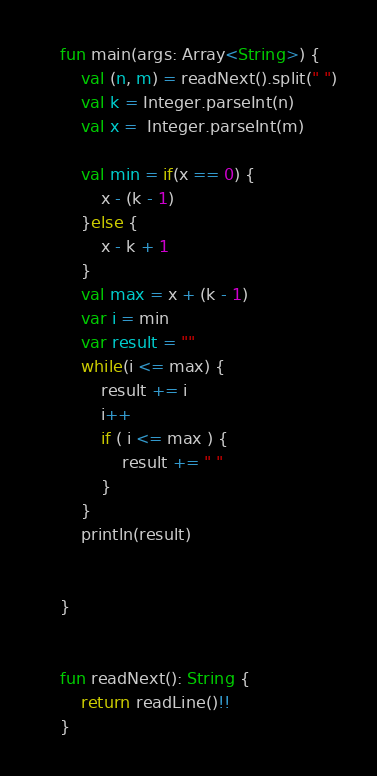Convert code to text. <code><loc_0><loc_0><loc_500><loc_500><_Kotlin_>
    fun main(args: Array<String>) {
        val (n, m) = readNext().split(" ")
        val k = Integer.parseInt(n)
        val x =  Integer.parseInt(m)

        val min = if(x == 0) {
            x - (k - 1)
        }else {
            x - k + 1
        }
        val max = x + (k - 1)
        var i = min
        var result = ""
        while(i <= max) {
            result += i
            i++
            if ( i <= max ) {
                result += " "
            }
        }
        println(result)


    }


    fun readNext(): String {
        return readLine()!!
    }
</code> 